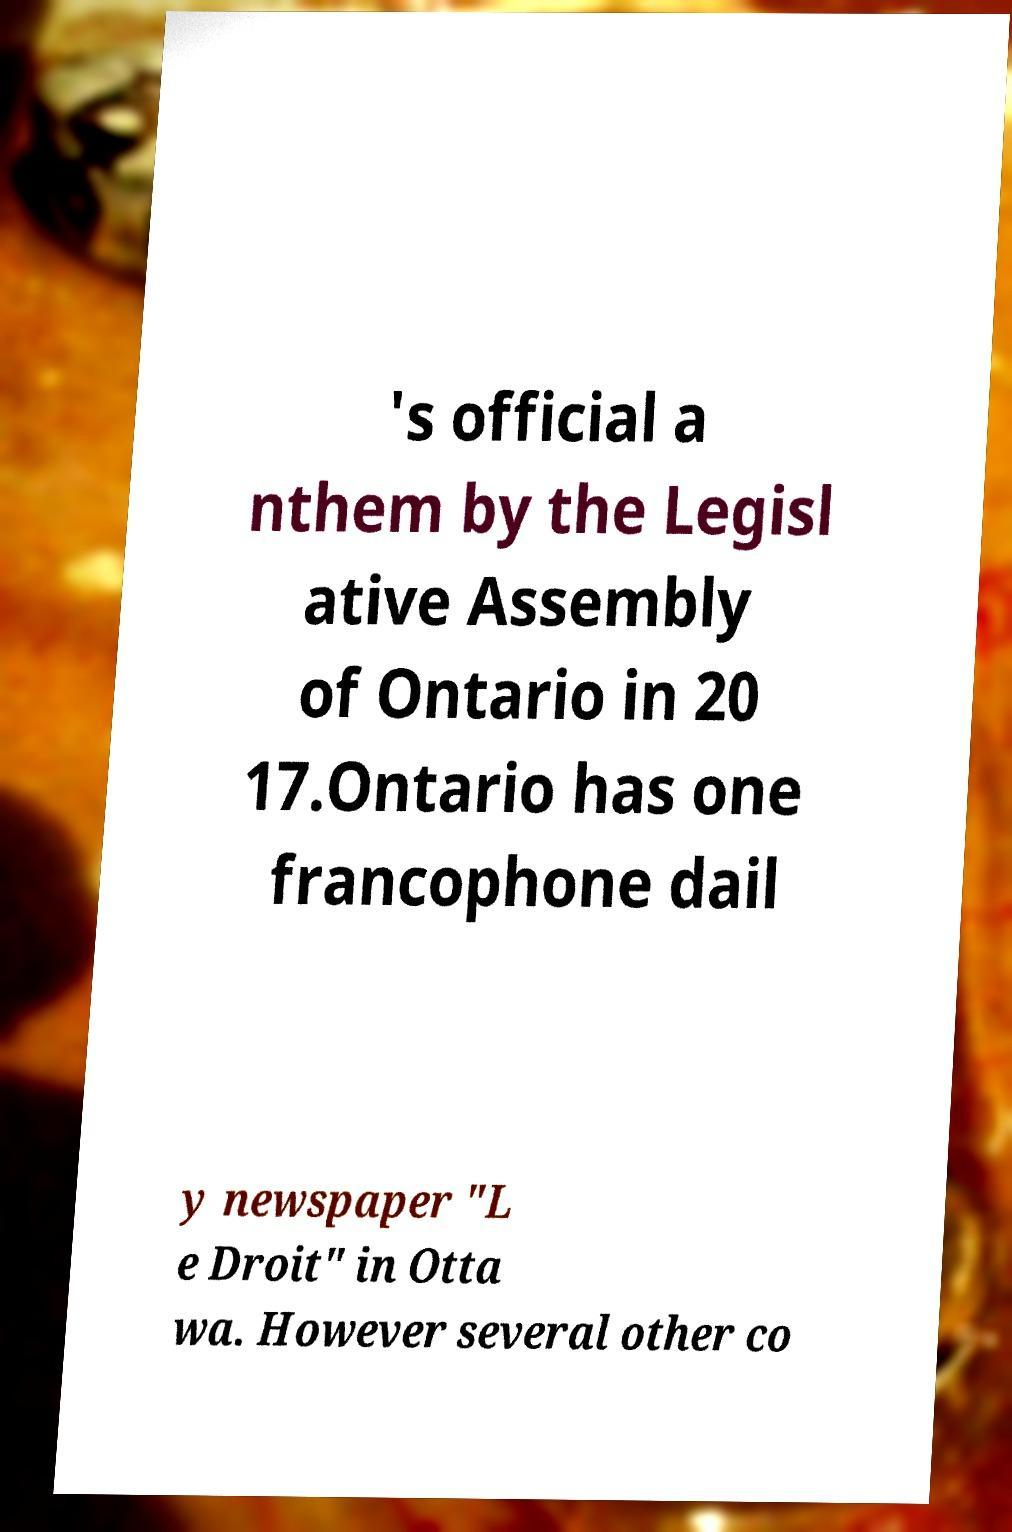There's text embedded in this image that I need extracted. Can you transcribe it verbatim? 's official a nthem by the Legisl ative Assembly of Ontario in 20 17.Ontario has one francophone dail y newspaper "L e Droit" in Otta wa. However several other co 